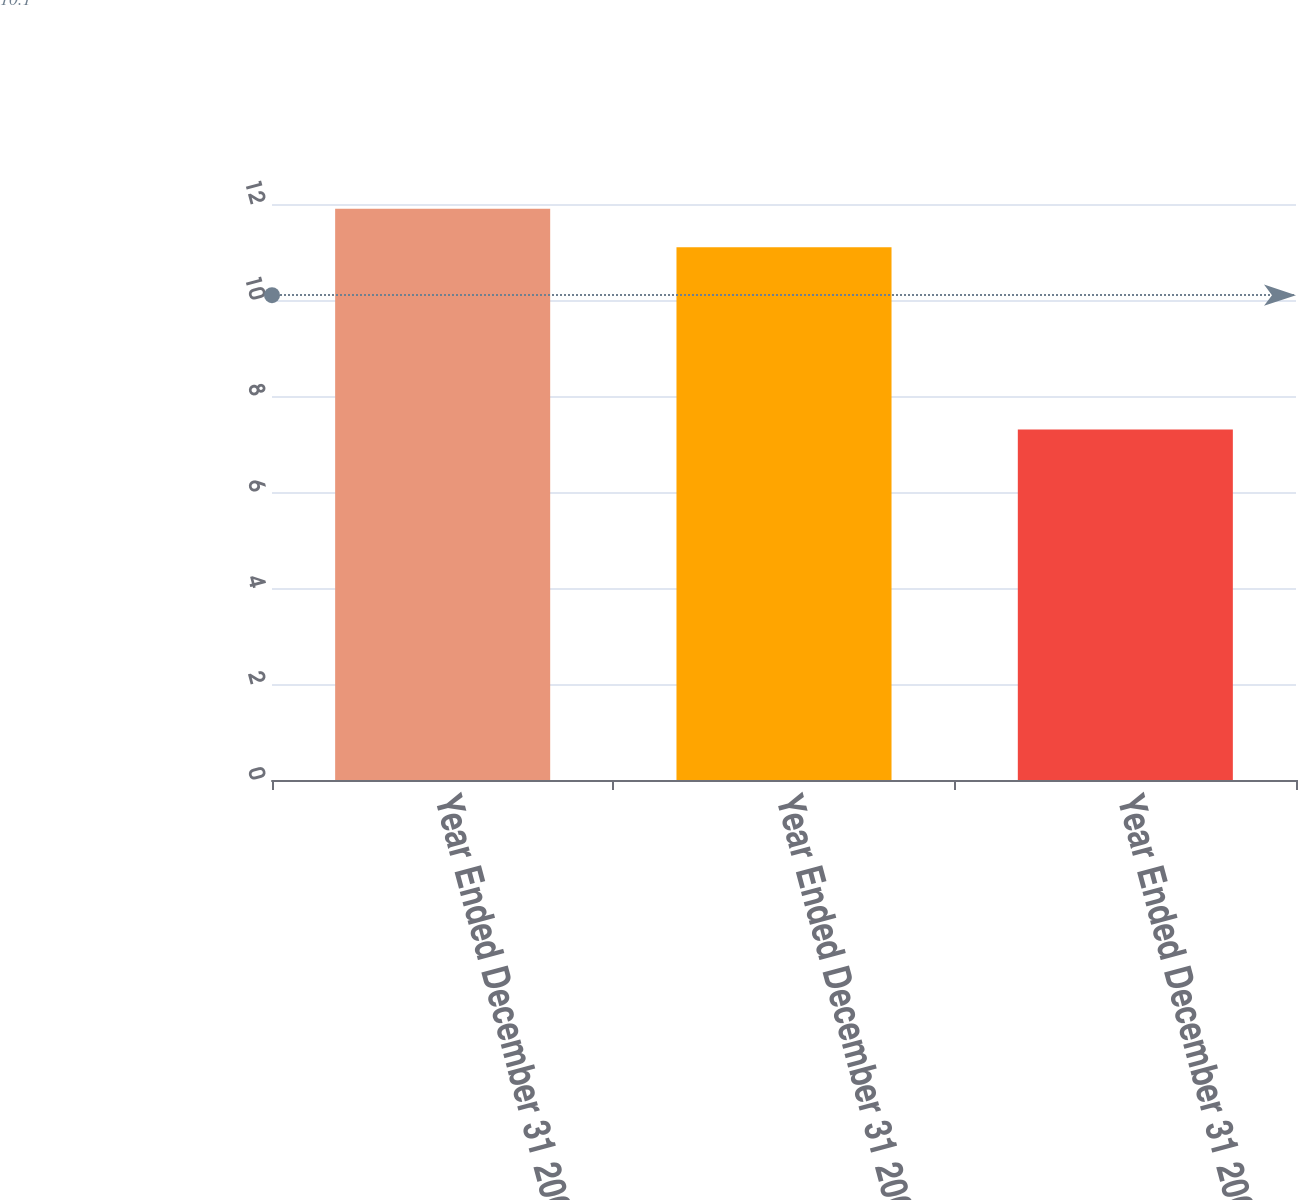<chart> <loc_0><loc_0><loc_500><loc_500><bar_chart><fcel>Year Ended December 31 2008<fcel>Year Ended December 31 2007<fcel>Year Ended December 31 2006<nl><fcel>11.9<fcel>11.1<fcel>7.3<nl></chart> 